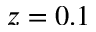Convert formula to latex. <formula><loc_0><loc_0><loc_500><loc_500>z = 0 . 1</formula> 